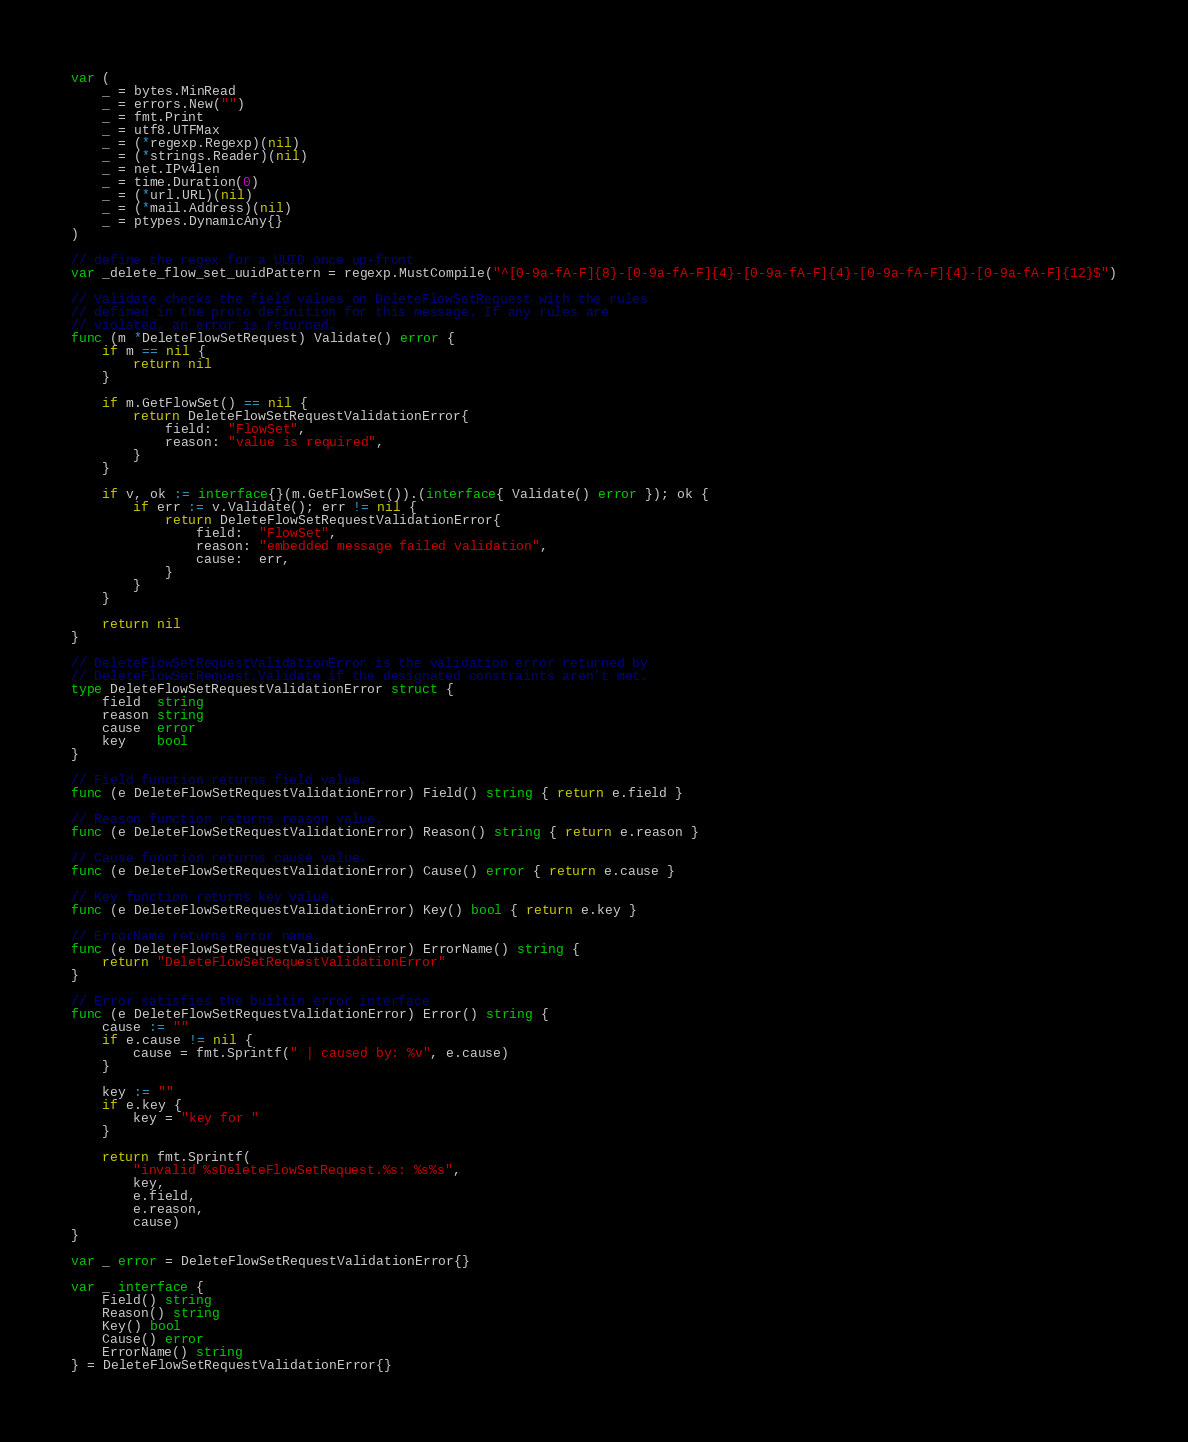<code> <loc_0><loc_0><loc_500><loc_500><_Go_>var (
	_ = bytes.MinRead
	_ = errors.New("")
	_ = fmt.Print
	_ = utf8.UTFMax
	_ = (*regexp.Regexp)(nil)
	_ = (*strings.Reader)(nil)
	_ = net.IPv4len
	_ = time.Duration(0)
	_ = (*url.URL)(nil)
	_ = (*mail.Address)(nil)
	_ = ptypes.DynamicAny{}
)

// define the regex for a UUID once up-front
var _delete_flow_set_uuidPattern = regexp.MustCompile("^[0-9a-fA-F]{8}-[0-9a-fA-F]{4}-[0-9a-fA-F]{4}-[0-9a-fA-F]{4}-[0-9a-fA-F]{12}$")

// Validate checks the field values on DeleteFlowSetRequest with the rules
// defined in the proto definition for this message. If any rules are
// violated, an error is returned.
func (m *DeleteFlowSetRequest) Validate() error {
	if m == nil {
		return nil
	}

	if m.GetFlowSet() == nil {
		return DeleteFlowSetRequestValidationError{
			field:  "FlowSet",
			reason: "value is required",
		}
	}

	if v, ok := interface{}(m.GetFlowSet()).(interface{ Validate() error }); ok {
		if err := v.Validate(); err != nil {
			return DeleteFlowSetRequestValidationError{
				field:  "FlowSet",
				reason: "embedded message failed validation",
				cause:  err,
			}
		}
	}

	return nil
}

// DeleteFlowSetRequestValidationError is the validation error returned by
// DeleteFlowSetRequest.Validate if the designated constraints aren't met.
type DeleteFlowSetRequestValidationError struct {
	field  string
	reason string
	cause  error
	key    bool
}

// Field function returns field value.
func (e DeleteFlowSetRequestValidationError) Field() string { return e.field }

// Reason function returns reason value.
func (e DeleteFlowSetRequestValidationError) Reason() string { return e.reason }

// Cause function returns cause value.
func (e DeleteFlowSetRequestValidationError) Cause() error { return e.cause }

// Key function returns key value.
func (e DeleteFlowSetRequestValidationError) Key() bool { return e.key }

// ErrorName returns error name.
func (e DeleteFlowSetRequestValidationError) ErrorName() string {
	return "DeleteFlowSetRequestValidationError"
}

// Error satisfies the builtin error interface
func (e DeleteFlowSetRequestValidationError) Error() string {
	cause := ""
	if e.cause != nil {
		cause = fmt.Sprintf(" | caused by: %v", e.cause)
	}

	key := ""
	if e.key {
		key = "key for "
	}

	return fmt.Sprintf(
		"invalid %sDeleteFlowSetRequest.%s: %s%s",
		key,
		e.field,
		e.reason,
		cause)
}

var _ error = DeleteFlowSetRequestValidationError{}

var _ interface {
	Field() string
	Reason() string
	Key() bool
	Cause() error
	ErrorName() string
} = DeleteFlowSetRequestValidationError{}
</code> 